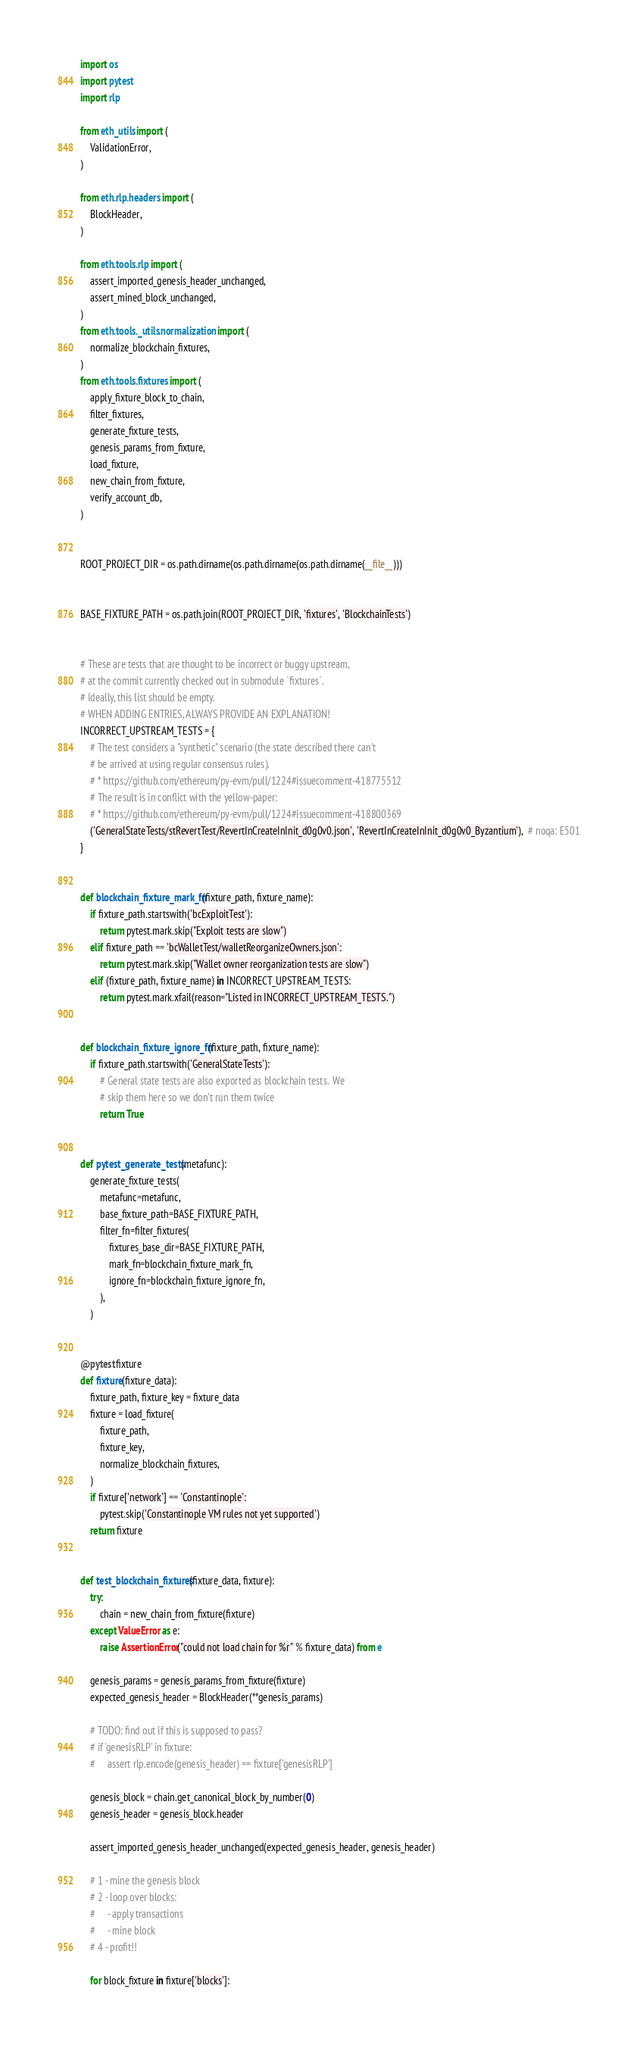Convert code to text. <code><loc_0><loc_0><loc_500><loc_500><_Python_>import os
import pytest
import rlp

from eth_utils import (
    ValidationError,
)

from eth.rlp.headers import (
    BlockHeader,
)

from eth.tools.rlp import (
    assert_imported_genesis_header_unchanged,
    assert_mined_block_unchanged,
)
from eth.tools._utils.normalization import (
    normalize_blockchain_fixtures,
)
from eth.tools.fixtures import (
    apply_fixture_block_to_chain,
    filter_fixtures,
    generate_fixture_tests,
    genesis_params_from_fixture,
    load_fixture,
    new_chain_from_fixture,
    verify_account_db,
)


ROOT_PROJECT_DIR = os.path.dirname(os.path.dirname(os.path.dirname(__file__)))


BASE_FIXTURE_PATH = os.path.join(ROOT_PROJECT_DIR, 'fixtures', 'BlockchainTests')


# These are tests that are thought to be incorrect or buggy upstream,
# at the commit currently checked out in submodule `fixtures`.
# Ideally, this list should be empty.
# WHEN ADDING ENTRIES, ALWAYS PROVIDE AN EXPLANATION!
INCORRECT_UPSTREAM_TESTS = {
    # The test considers a "synthetic" scenario (the state described there can't
    # be arrived at using regular consensus rules).
    # * https://github.com/ethereum/py-evm/pull/1224#issuecomment-418775512
    # The result is in conflict with the yellow-paper:
    # * https://github.com/ethereum/py-evm/pull/1224#issuecomment-418800369
    ('GeneralStateTests/stRevertTest/RevertInCreateInInit_d0g0v0.json', 'RevertInCreateInInit_d0g0v0_Byzantium'),  # noqa: E501
}


def blockchain_fixture_mark_fn(fixture_path, fixture_name):
    if fixture_path.startswith('bcExploitTest'):
        return pytest.mark.skip("Exploit tests are slow")
    elif fixture_path == 'bcWalletTest/walletReorganizeOwners.json':
        return pytest.mark.skip("Wallet owner reorganization tests are slow")
    elif (fixture_path, fixture_name) in INCORRECT_UPSTREAM_TESTS:
        return pytest.mark.xfail(reason="Listed in INCORRECT_UPSTREAM_TESTS.")


def blockchain_fixture_ignore_fn(fixture_path, fixture_name):
    if fixture_path.startswith('GeneralStateTests'):
        # General state tests are also exported as blockchain tests.  We
        # skip them here so we don't run them twice
        return True


def pytest_generate_tests(metafunc):
    generate_fixture_tests(
        metafunc=metafunc,
        base_fixture_path=BASE_FIXTURE_PATH,
        filter_fn=filter_fixtures(
            fixtures_base_dir=BASE_FIXTURE_PATH,
            mark_fn=blockchain_fixture_mark_fn,
            ignore_fn=blockchain_fixture_ignore_fn,
        ),
    )


@pytest.fixture
def fixture(fixture_data):
    fixture_path, fixture_key = fixture_data
    fixture = load_fixture(
        fixture_path,
        fixture_key,
        normalize_blockchain_fixtures,
    )
    if fixture['network'] == 'Constantinople':
        pytest.skip('Constantinople VM rules not yet supported')
    return fixture


def test_blockchain_fixtures(fixture_data, fixture):
    try:
        chain = new_chain_from_fixture(fixture)
    except ValueError as e:
        raise AssertionError("could not load chain for %r" % fixture_data) from e

    genesis_params = genesis_params_from_fixture(fixture)
    expected_genesis_header = BlockHeader(**genesis_params)

    # TODO: find out if this is supposed to pass?
    # if 'genesisRLP' in fixture:
    #     assert rlp.encode(genesis_header) == fixture['genesisRLP']

    genesis_block = chain.get_canonical_block_by_number(0)
    genesis_header = genesis_block.header

    assert_imported_genesis_header_unchanged(expected_genesis_header, genesis_header)

    # 1 - mine the genesis block
    # 2 - loop over blocks:
    #     - apply transactions
    #     - mine block
    # 4 - profit!!

    for block_fixture in fixture['blocks']:</code> 